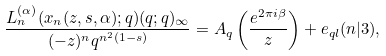<formula> <loc_0><loc_0><loc_500><loc_500>\frac { L _ { n } ^ { ( \alpha ) } ( x _ { n } ( z , s , \alpha ) ; q ) ( q ; q ) _ { \infty } } { ( - z ) ^ { n } q ^ { n ^ { 2 } ( 1 - s ) } } = A _ { q } \left ( \frac { e ^ { 2 \pi i \beta } } { z } \right ) + e _ { q l } ( n | 3 ) ,</formula> 